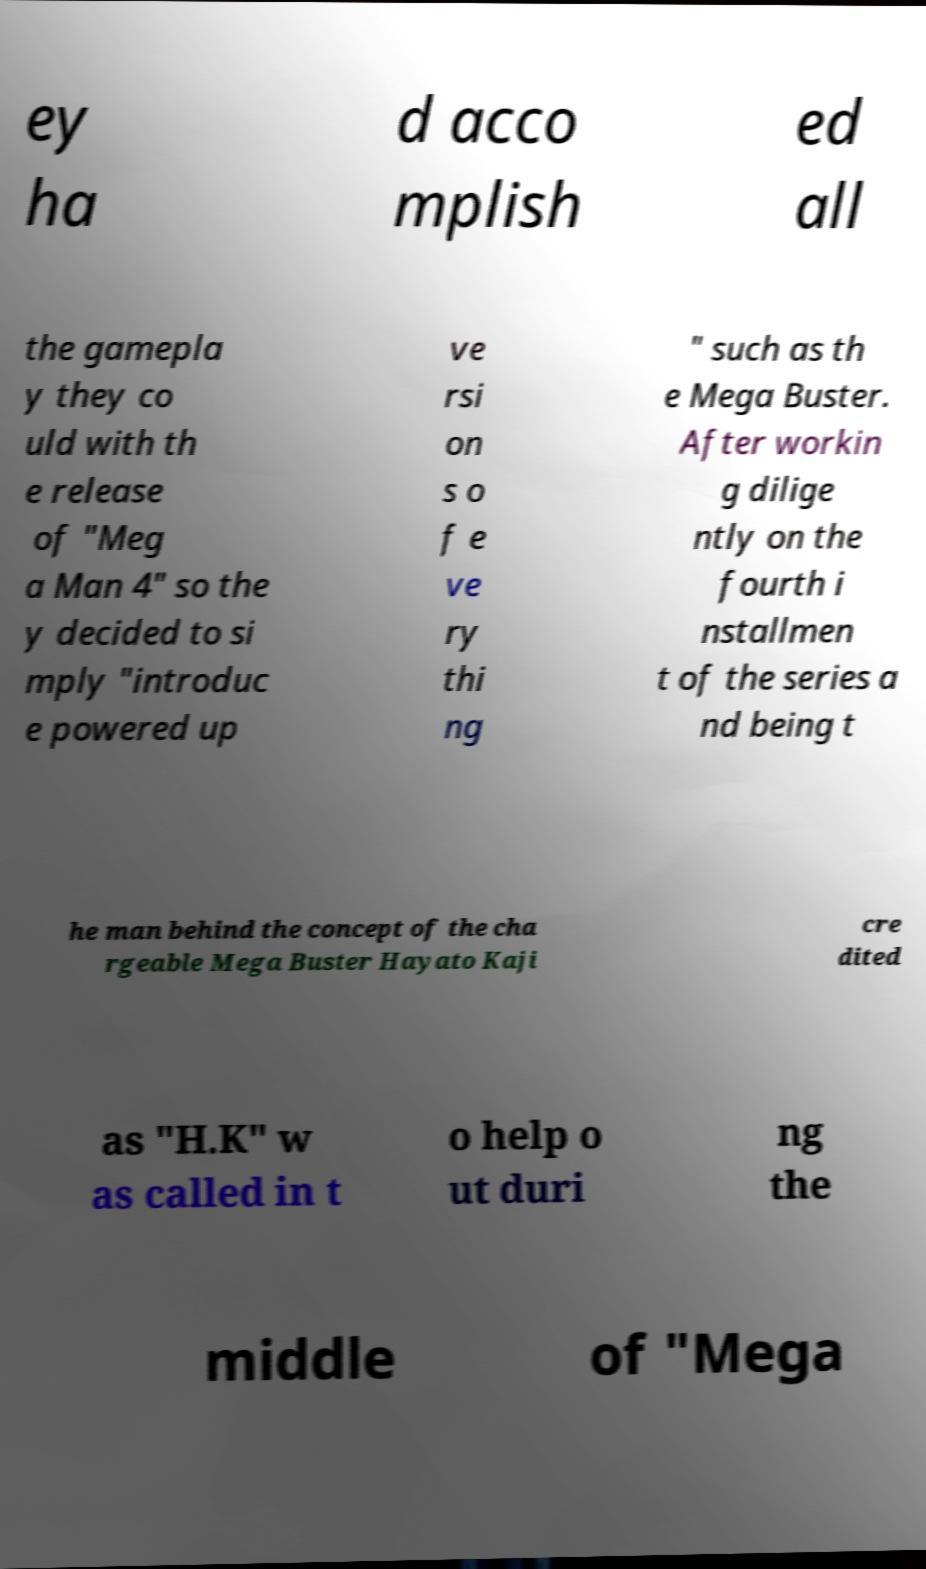What messages or text are displayed in this image? I need them in a readable, typed format. ey ha d acco mplish ed all the gamepla y they co uld with th e release of "Meg a Man 4" so the y decided to si mply "introduc e powered up ve rsi on s o f e ve ry thi ng " such as th e Mega Buster. After workin g dilige ntly on the fourth i nstallmen t of the series a nd being t he man behind the concept of the cha rgeable Mega Buster Hayato Kaji cre dited as "H.K" w as called in t o help o ut duri ng the middle of "Mega 